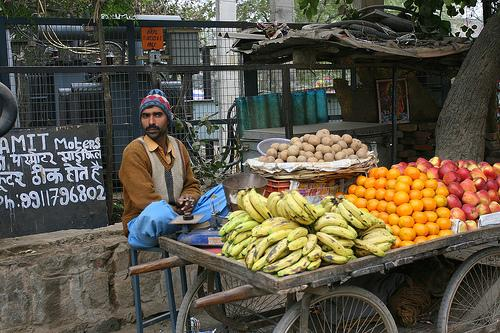Identify the type of headwear the man is wearing and describe the colors. The man is wearing a colorful knitted hat or beanie with various colors, including red, blue, green, and yellow. What is the main activity the man in the picture is engaged in, and what is the main item he is selling? The man is sitting on a stool, selling fruit and vegetables from a wooden cart. Describe the scene behind the man and the position of the sign with information on it. Behind the man, there is a wire fence, and there's a black and white sign with information not in English to his left side. Which type of fruit occupies the largest area on the cart? Bunches of bananas occupy the largest area on the cart, with a width of 212 and a height of 212. Explain what the image would be suitable for in terms of advertisement purposes. The image would be suitable for promoting a local farmer's market, showcasing the variety of fresh fruits and vegetables available for sale. 